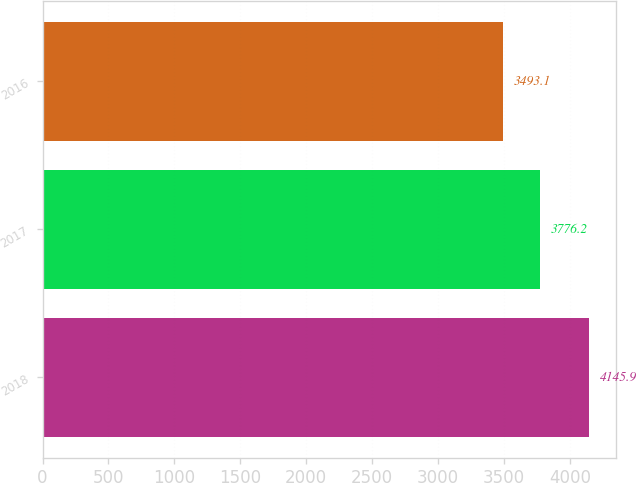Convert chart to OTSL. <chart><loc_0><loc_0><loc_500><loc_500><bar_chart><fcel>2018<fcel>2017<fcel>2016<nl><fcel>4145.9<fcel>3776.2<fcel>3493.1<nl></chart> 